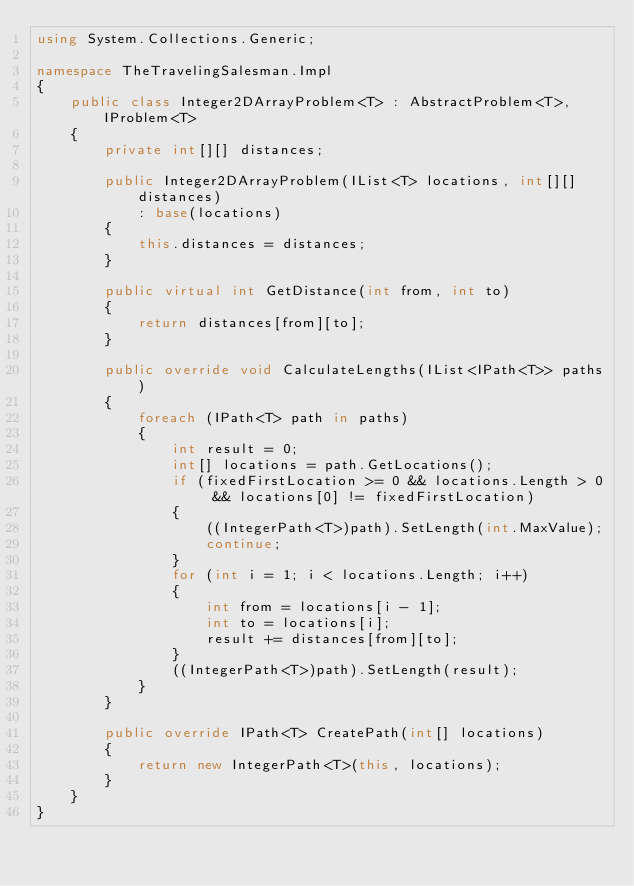Convert code to text. <code><loc_0><loc_0><loc_500><loc_500><_C#_>using System.Collections.Generic;

namespace TheTravelingSalesman.Impl
{
    public class Integer2DArrayProblem<T> : AbstractProblem<T>, IProblem<T>
    {
        private int[][] distances;

        public Integer2DArrayProblem(IList<T> locations, int[][] distances)
            : base(locations)
        {
            this.distances = distances;
        }

        public virtual int GetDistance(int from, int to)
        {
            return distances[from][to];
        }

        public override void CalculateLengths(IList<IPath<T>> paths)
        {
            foreach (IPath<T> path in paths)
            {
                int result = 0;
                int[] locations = path.GetLocations();
                if (fixedFirstLocation >= 0 && locations.Length > 0 && locations[0] != fixedFirstLocation)
                {
                    ((IntegerPath<T>)path).SetLength(int.MaxValue);
                    continue;
                }
                for (int i = 1; i < locations.Length; i++)
                {
                    int from = locations[i - 1];
                    int to = locations[i];
                    result += distances[from][to];
                }
                ((IntegerPath<T>)path).SetLength(result);
            }
        }

        public override IPath<T> CreatePath(int[] locations)
        {
            return new IntegerPath<T>(this, locations);
        }
    }
}</code> 